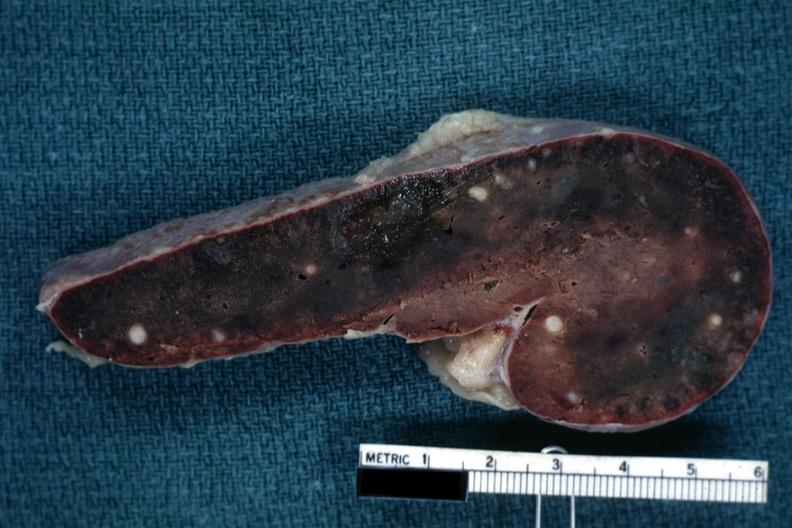how is fixed tissue cut surface congested parenchyma with granulomas?
Answer the question using a single word or phrase. Obvious 